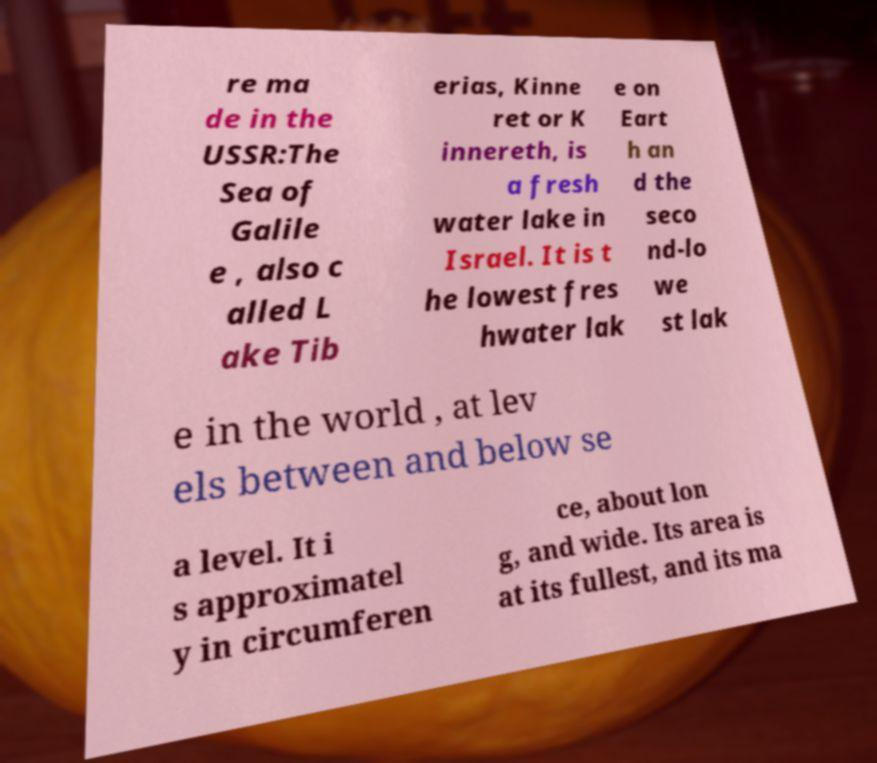Could you assist in decoding the text presented in this image and type it out clearly? re ma de in the USSR:The Sea of Galile e , also c alled L ake Tib erias, Kinne ret or K innereth, is a fresh water lake in Israel. It is t he lowest fres hwater lak e on Eart h an d the seco nd-lo we st lak e in the world , at lev els between and below se a level. It i s approximatel y in circumferen ce, about lon g, and wide. Its area is at its fullest, and its ma 